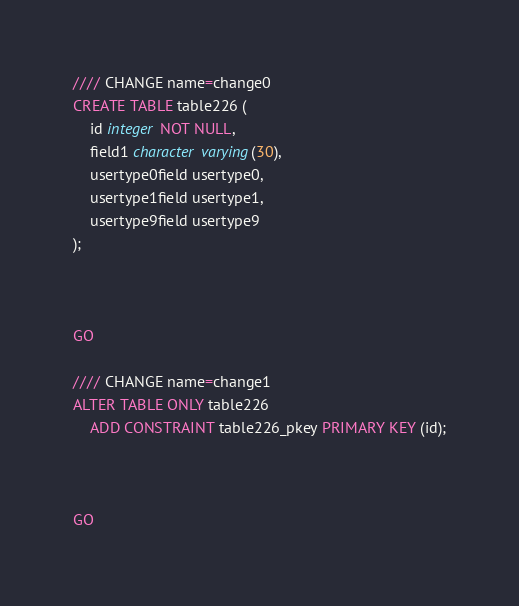<code> <loc_0><loc_0><loc_500><loc_500><_SQL_>//// CHANGE name=change0
CREATE TABLE table226 (
    id integer NOT NULL,
    field1 character varying(30),
    usertype0field usertype0,
    usertype1field usertype1,
    usertype9field usertype9
);



GO

//// CHANGE name=change1
ALTER TABLE ONLY table226
    ADD CONSTRAINT table226_pkey PRIMARY KEY (id);



GO
</code> 